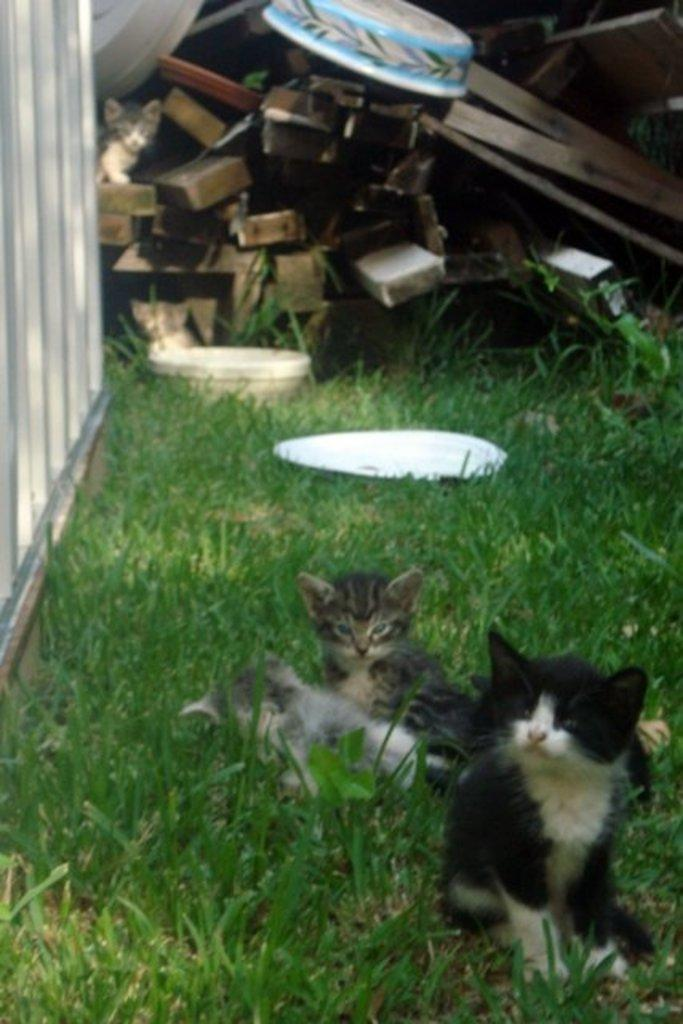What type of material is used for the planks in the image? The wooden planks in the image are made of wood. What is placed on the wooden planks? There is a bowl on the wooden planks. What animal is visible on the wooden planks? There is a cat visible on the wooden planks. How many cats are visible in the foreground of the image? There are three cats visible on the grass in the foreground. What type of vessel is being used for the meeting in the image? There is no vessel or meeting present in the image; it features wooden planks, a bowl, a cat, and three cats in the foreground. 